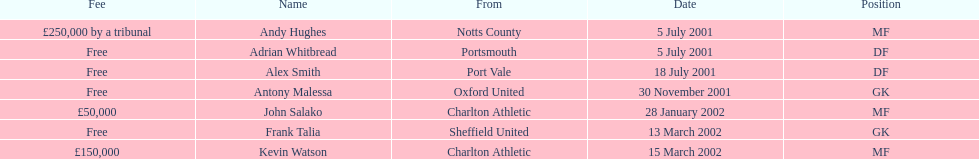What are all of the names? Andy Hughes, Adrian Whitbread, Alex Smith, Antony Malessa, John Salako, Frank Talia, Kevin Watson. What was the fee for each person? £250,000 by a tribunal, Free, Free, Free, £50,000, Free, £150,000. And who had the highest fee? Andy Hughes. 